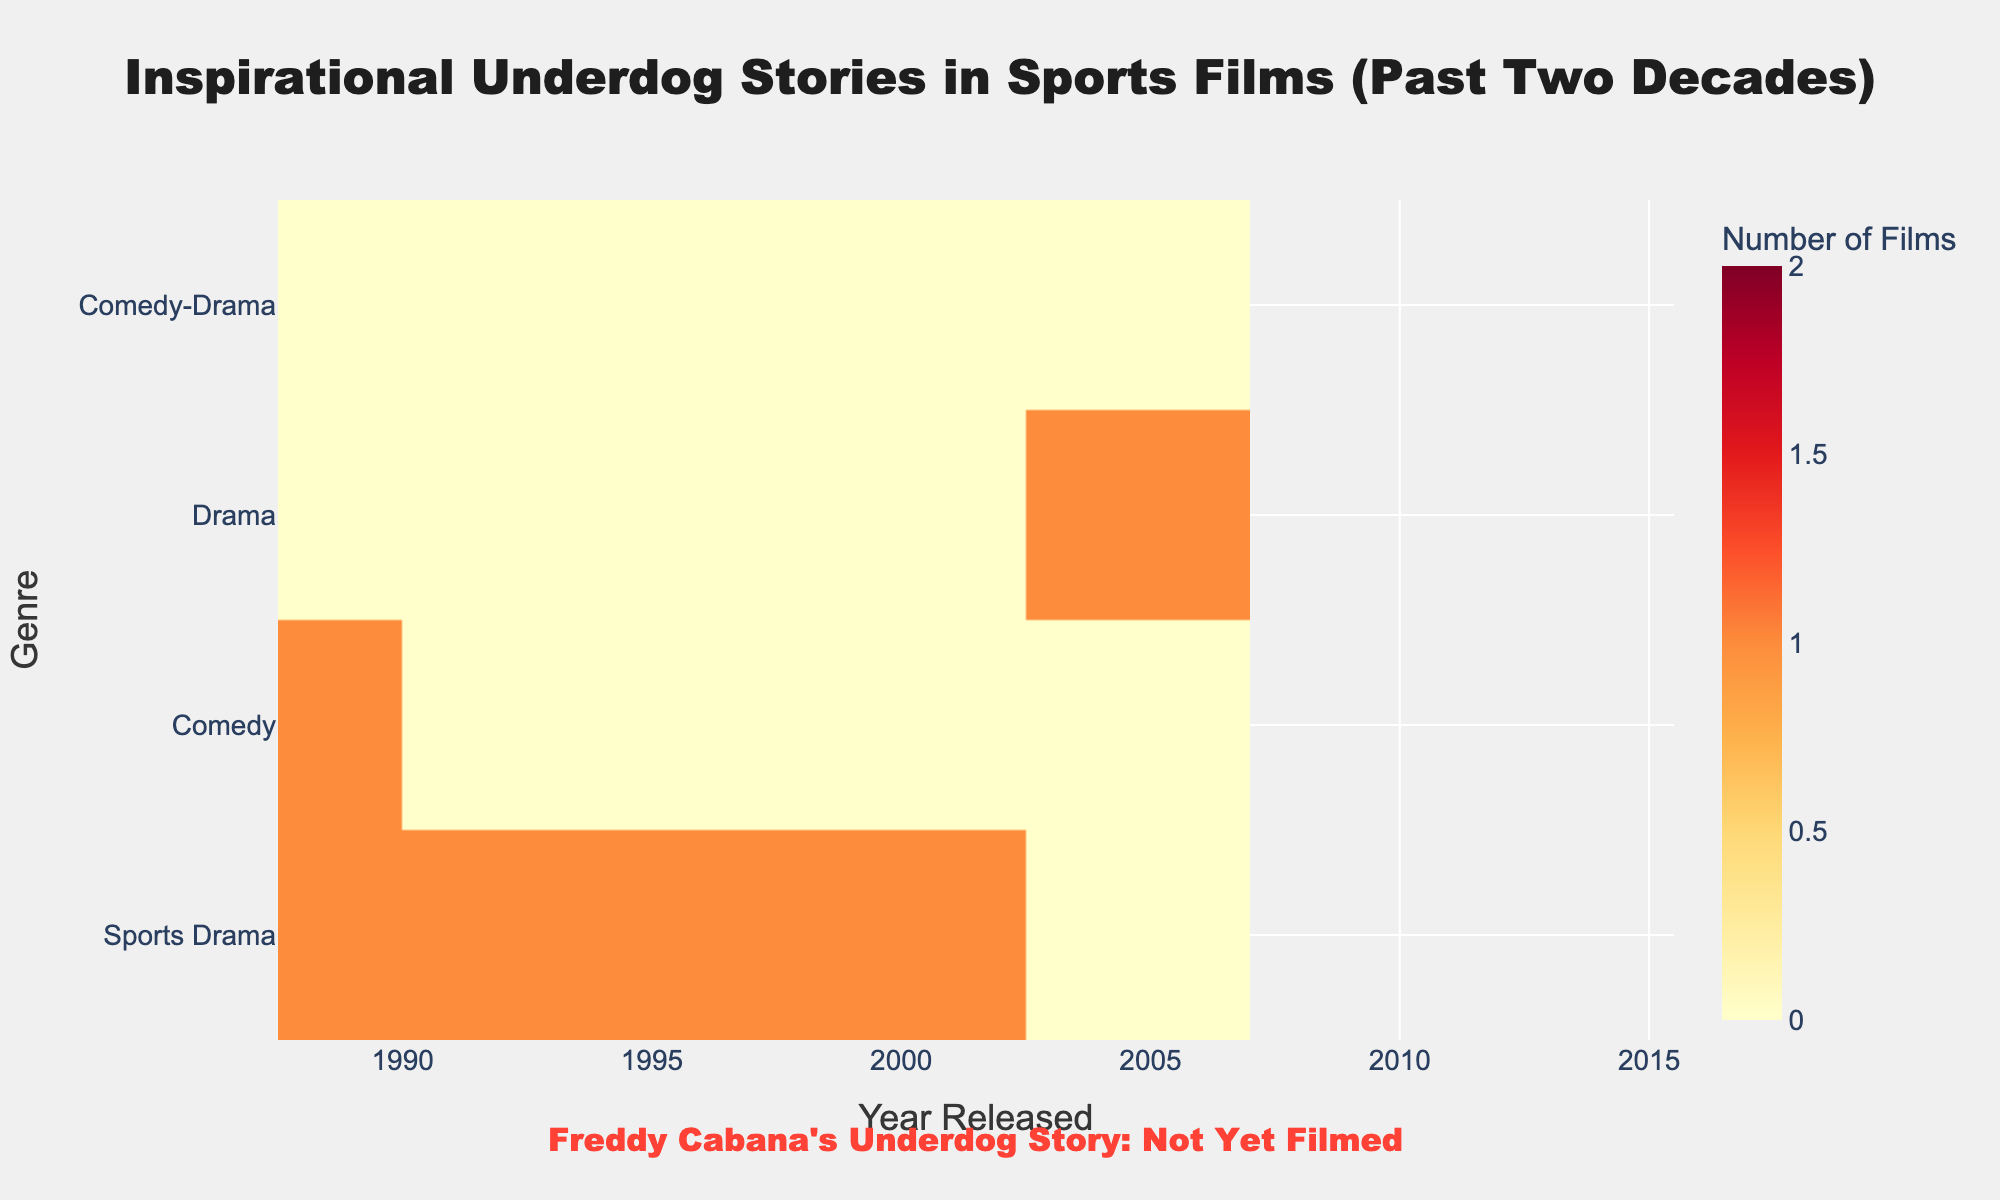What is the title of the heatmap? The title is located at the top center of the heatmap figure, which provides a general description of the data visualized.
Answer: Inspirational Underdog Stories in Sports Films (Past Two Decades) What does the color scale represent on the heatmap? The color scale positioned alongside the heatmap indicates the number of films corresponding to each genre and year released. Brighter colors (yellow and orange) denote a higher number of films, while darker colors (red) denote fewer films.
Answer: Number of Films How many genres are represented in the heatmap? The genres are listed along the vertical (y) axis of the heatmap. By counting these unique categories, we can determine the total number represented.
Answer: 6 Which genre has the highest number of films released in a single year? By observing the heatmap for the brightest color in any genre row, we can identify the genre with the highest number in a single year.
Answer: Drama How many films were released in the year 2005? Sum the values corresponding to the year 2005 across all genres in the heatmap. This involves adding the counts from each row for the column representing 2005.
Answer: 3 Which year had the most diverse representation of genres? Identify the year with the highest number of different genres participating. This can be determined by noting multiple non-zero cells within the same column on the heatmap.
Answer: Probably 2006 or another year with multiple genre entries Between sports drama and drama genres, which has more films released in total? Count the number of films in each genre across all years by summing the cells in their respective rows and compare the totals.
Answer: Sports Drama How are comedy and comedy-drama genres represented across the two decades? Observe the heatmap to note the distribution of films under comedy and comedy-drama across the years. Count the total occurrences and describe the spread over the time period.
Answer: Scattered and less frequent compared to other genres Which year appears to have the highest overall activity? Look for the year column with the highest cumulative brightness. Sum the film counts for each year across all genres and identify the year with the highest value.
Answer: The specific year with maximum releases (not provided here) Does the heatmap show any mention of Freddy Cabana's underdog story? Refer to the annotation text at the bottom of the heatmap to see if there is any specific mention of Freddy Cabana's underdog story.
Answer: No 